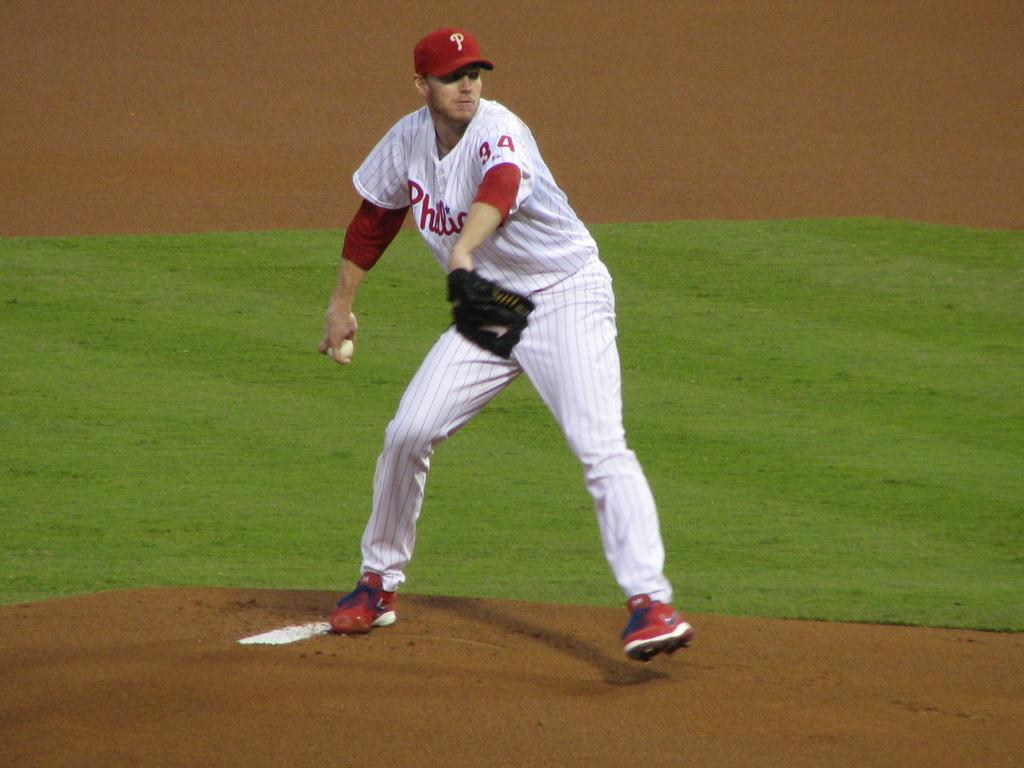<image>
Render a clear and concise summary of the photo. A person in a Phillies uniform is about to throw a baseball. 